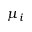<formula> <loc_0><loc_0><loc_500><loc_500>\mu _ { i }</formula> 